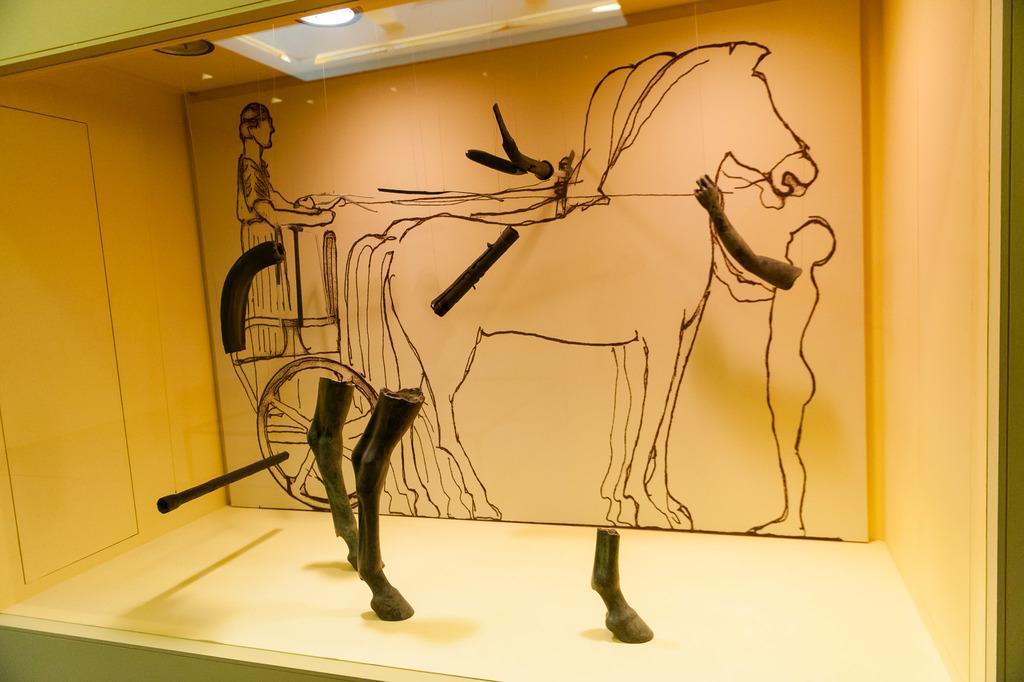Can you describe this image briefly? In the picture i can see a painting of horses which is on wall, we can see some wooden sticks. 